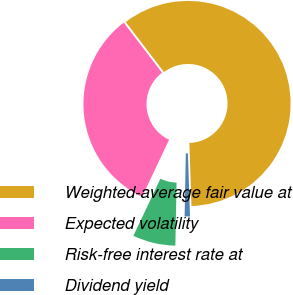Convert chart. <chart><loc_0><loc_0><loc_500><loc_500><pie_chart><fcel>Weighted-average fair value at<fcel>Expected volatility<fcel>Risk-free interest rate at<fcel>Dividend yield<nl><fcel>59.85%<fcel>32.56%<fcel>6.74%<fcel>0.84%<nl></chart> 